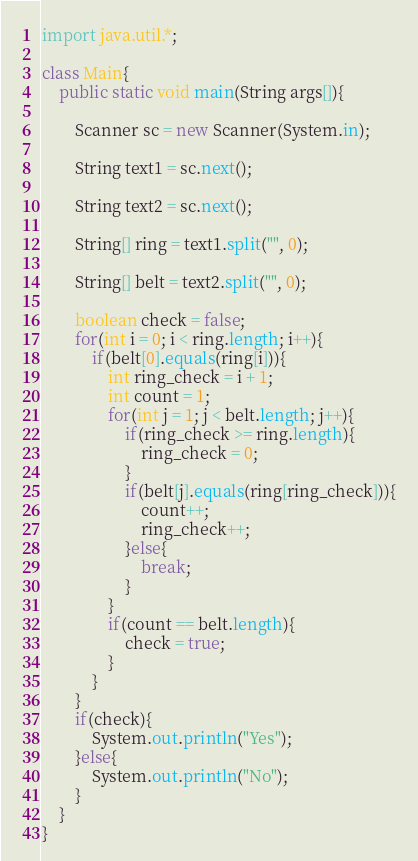Convert code to text. <code><loc_0><loc_0><loc_500><loc_500><_Java_>import java.util.*;

class Main{
    public static void main(String args[]){
        
        Scanner sc = new Scanner(System.in);

        String text1 = sc.next();

        String text2 = sc.next();

        String[] ring = text1.split("", 0);

        String[] belt = text2.split("", 0);

        boolean check = false;
        for(int i = 0; i < ring.length; i++){
            if(belt[0].equals(ring[i])){
                int ring_check = i + 1;
                int count = 1;
                for(int j = 1; j < belt.length; j++){
                    if(ring_check >= ring.length){
                        ring_check = 0;
                    }
                    if(belt[j].equals(ring[ring_check])){
                        count++;
                        ring_check++;
                    }else{
                        break;
                    }
                }
                if(count == belt.length){
                    check = true;
                }
            }
        }
        if(check){
            System.out.println("Yes");
        }else{
            System.out.println("No");
        }
    }
}
</code> 